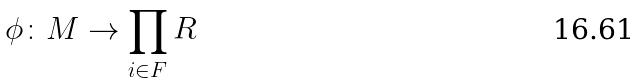<formula> <loc_0><loc_0><loc_500><loc_500>\phi \colon M \rightarrow \prod _ { i \in F } R</formula> 